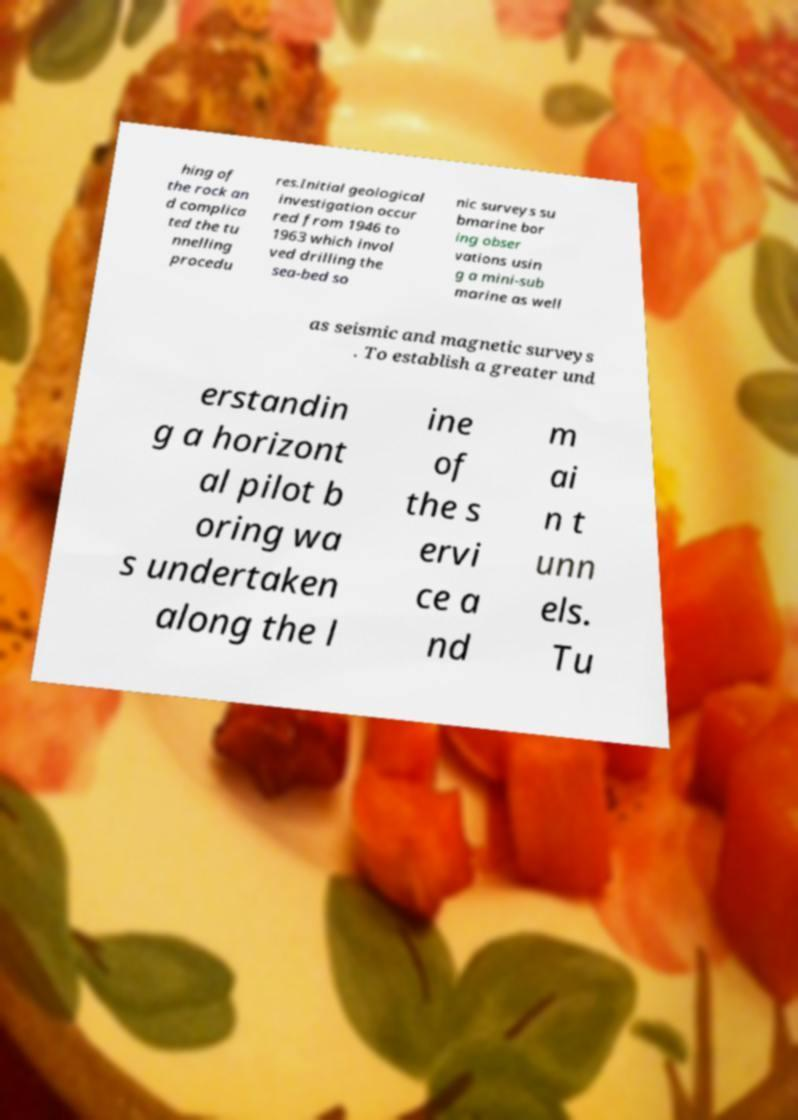Can you accurately transcribe the text from the provided image for me? hing of the rock an d complica ted the tu nnelling procedu res.Initial geological investigation occur red from 1946 to 1963 which invol ved drilling the sea-bed so nic surveys su bmarine bor ing obser vations usin g a mini-sub marine as well as seismic and magnetic surveys . To establish a greater und erstandin g a horizont al pilot b oring wa s undertaken along the l ine of the s ervi ce a nd m ai n t unn els. Tu 